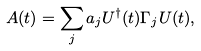Convert formula to latex. <formula><loc_0><loc_0><loc_500><loc_500>A ( t ) = \sum _ { j } a _ { j } U ^ { \dag } ( t ) \Gamma _ { j } U ( t ) ,</formula> 